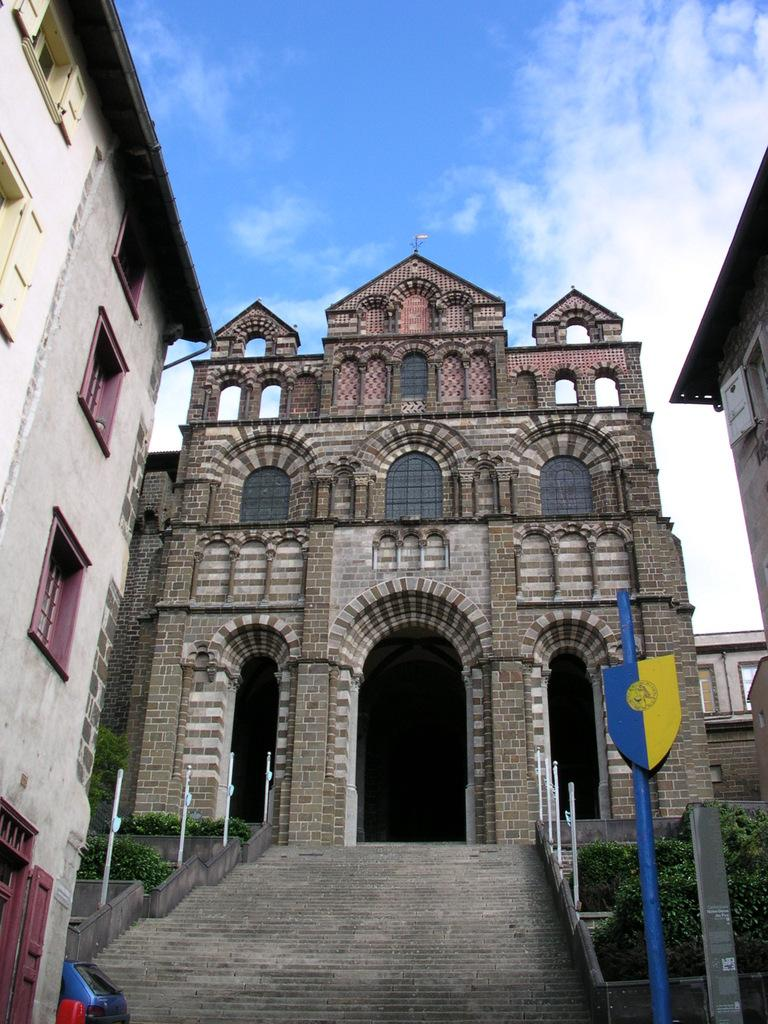What type of structures can be seen in the image? There are many buildings in the image. What feature is visible on the buildings? There are windows visible on the buildings. What architectural element can be seen in the image? There are stairs in the image. What object is present in the image that is typically used for support? A pole is present in the image. What type of vegetation is visible in the image? There is grass in the image. What type of plant is present in the image? There is a plant in the image. What is the condition of the sky in the image? The sky is cloudy in the image. What type of transportation is visible in the image? A vehicle is visible in the image. What type of scissors can be seen cutting the clouds in the image? There are no scissors present in the image, and the clouds are not being cut. How many quarters are visible on the vehicle in the image? There are no quarters visible on the vehicle in the image. 